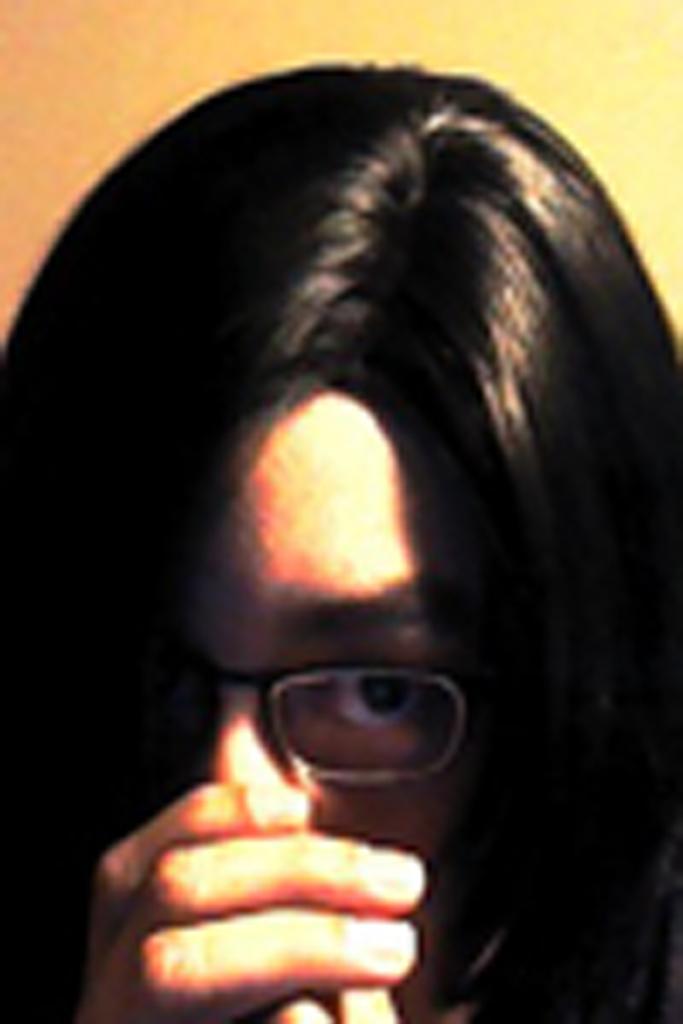How would you summarize this image in a sentence or two? In this image we can a lady, and the background is blurred. 